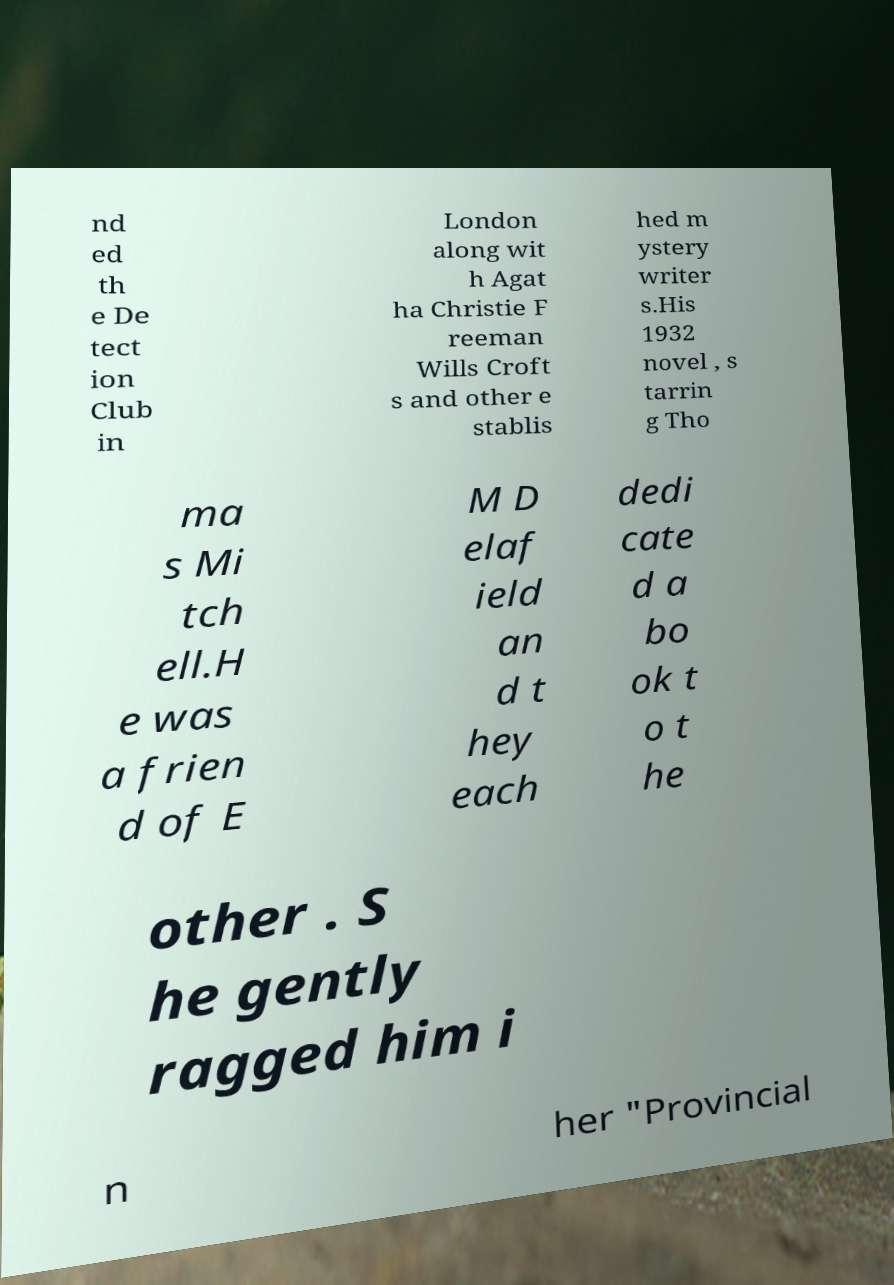What messages or text are displayed in this image? I need them in a readable, typed format. nd ed th e De tect ion Club in London along wit h Agat ha Christie F reeman Wills Croft s and other e stablis hed m ystery writer s.His 1932 novel , s tarrin g Tho ma s Mi tch ell.H e was a frien d of E M D elaf ield an d t hey each dedi cate d a bo ok t o t he other . S he gently ragged him i n her "Provincial 